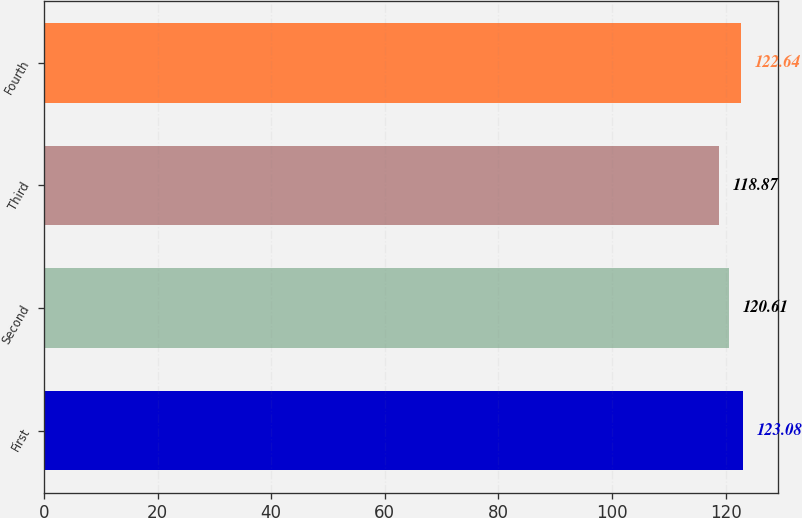Convert chart. <chart><loc_0><loc_0><loc_500><loc_500><bar_chart><fcel>First<fcel>Second<fcel>Third<fcel>Fourth<nl><fcel>123.08<fcel>120.61<fcel>118.87<fcel>122.64<nl></chart> 